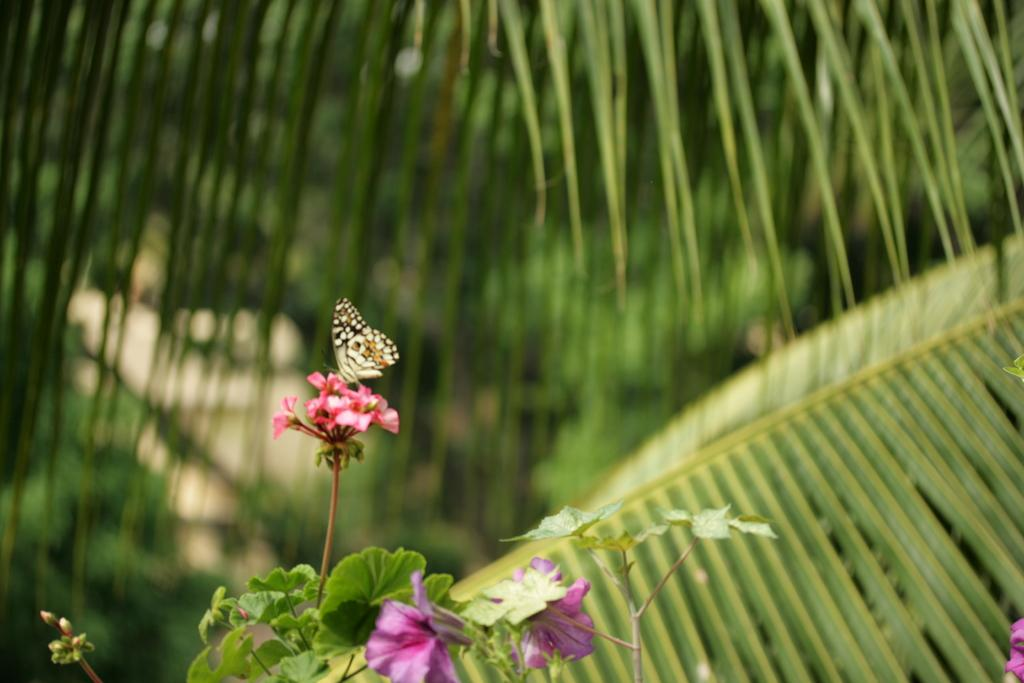What is the main subject of the image? There is a butterfly on flowers in the image. What type of vegetation can be seen in the image? There are trees and flower plants in the image. How is the background of the image depicted? The background of the image is blurred. How many jellyfish can be seen swimming in the image? There are no jellyfish present in the image; it features a butterfly on flowers. What color is the map in the image? There is no map present in the image. 